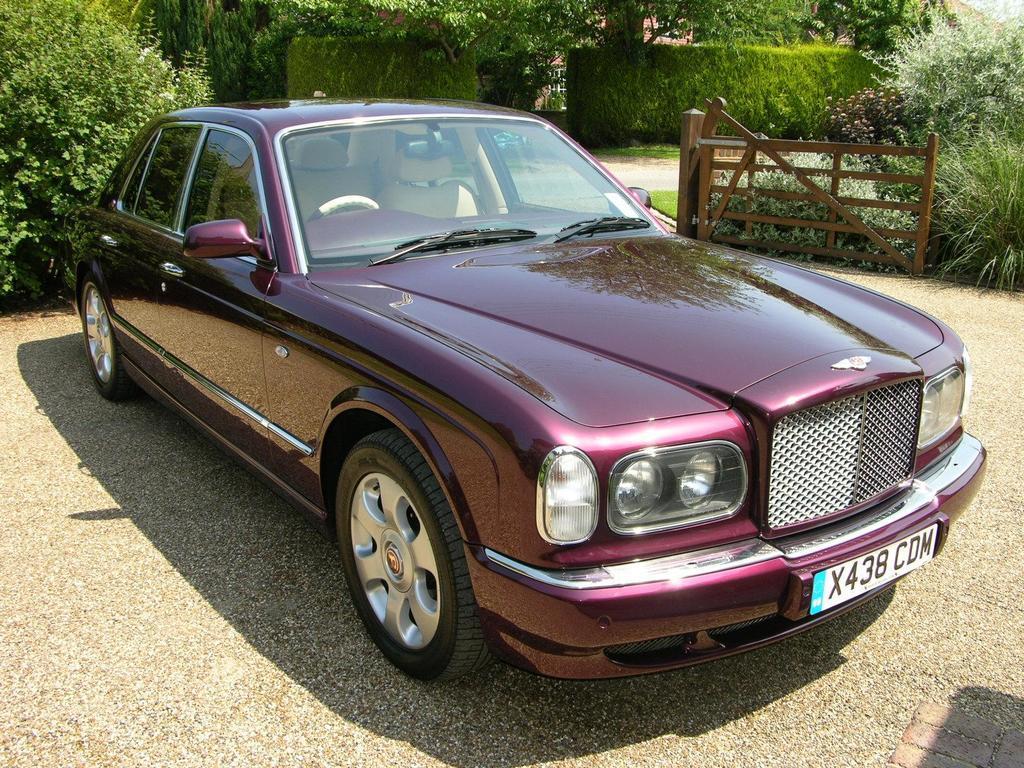Could you give a brief overview of what you see in this image? In this picture, we can see a vehicle, ground, plants, and wooden fencing. 